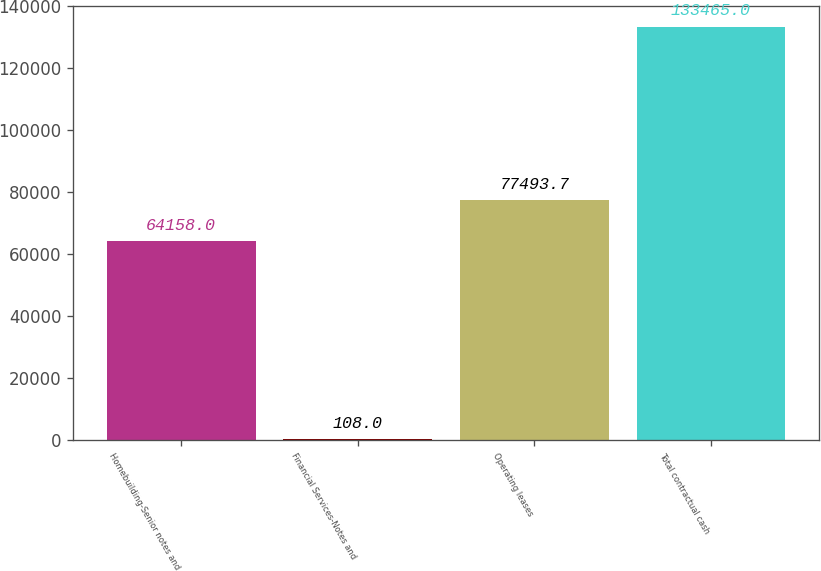Convert chart to OTSL. <chart><loc_0><loc_0><loc_500><loc_500><bar_chart><fcel>Homebuilding-Senior notes and<fcel>Financial Services-Notes and<fcel>Operating leases<fcel>Total contractual cash<nl><fcel>64158<fcel>108<fcel>77493.7<fcel>133465<nl></chart> 